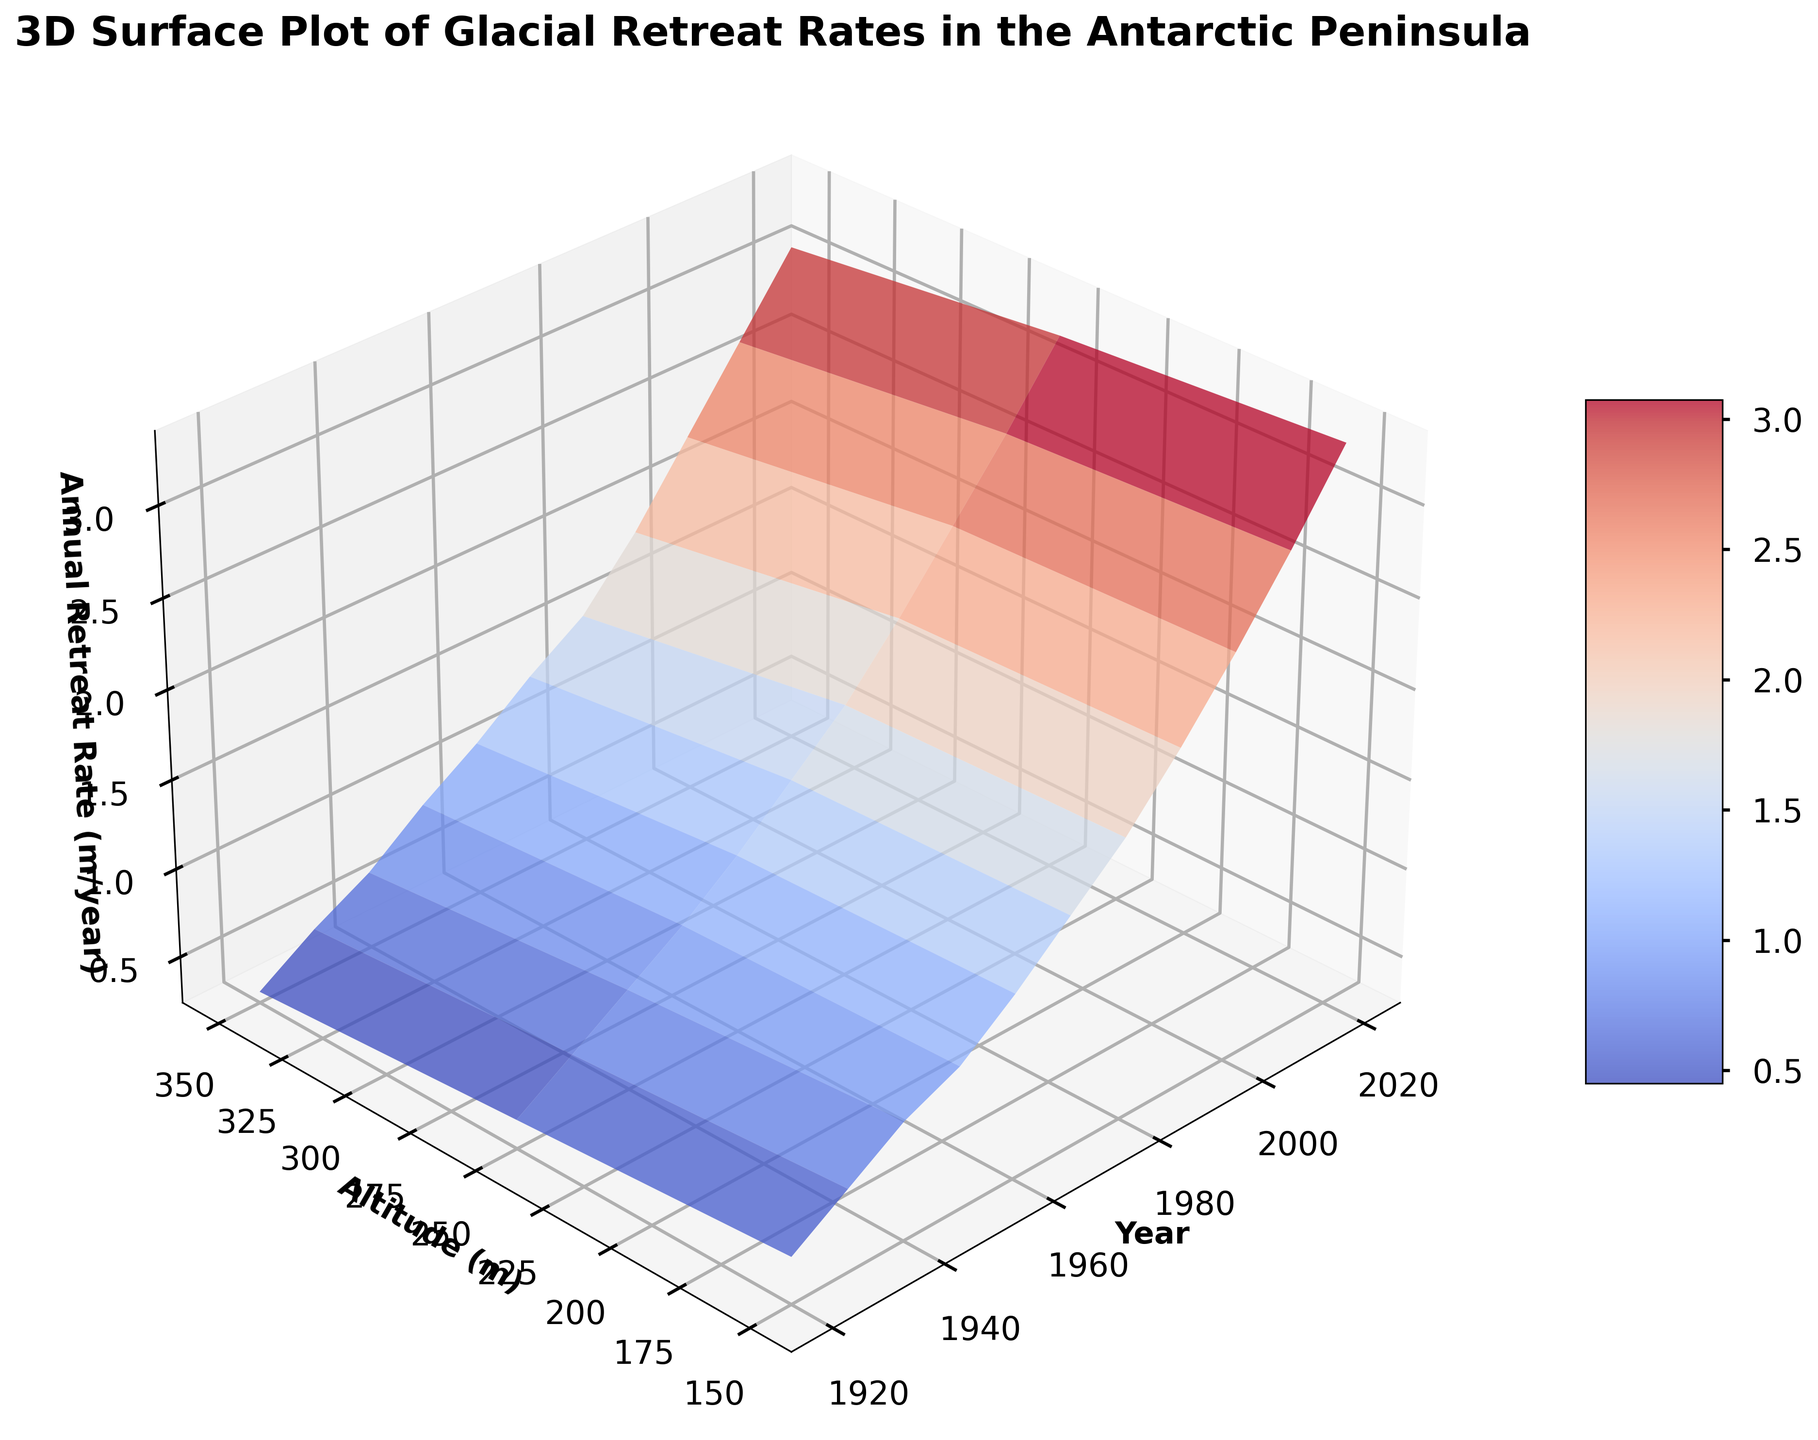What trend can you observe in the annual retreat rates over the years? To find the trend, look at how the annual retreat rates change over time. Observe the surface's color gradient and height. As the years progress from 1920 to 2020, the plot shows a general increase in the annual retreat rates, indicating an upward trend in glacial retreat rates.
Answer: Increasing trend How does the retreat rate compare between altitudes of 150 meters and 350 meters in 2020? To compare the retreat rates at 150 meters and 350 meters in 2020, look at the corresponding spots on the surface for the two altitudes in the year 2020. The altitude of 150 meters shows a higher retreat rate than the altitude of 350 meters.
Answer: Higher at 150 meters Which year shows the steepest increase in the annual retreat rate compared to the previous decade? To determine the steepest increase, observe the height difference between surfaces in consecutive decades. Between 1980 and 1990, the change in height is very steep, indicating a significant increase in the retreat rate in 1990 compared to 1980.
Answer: 1990 What is the average annual retreat rate in 2020 across all altitudes? Find the retreat rates for all altitudes in 2020 and calculate the average. The rates are approximately 3.4, 3.5, and 3.3. So, the average is (3.4 + 3.5 + 3.3) / 3 = 3.4
Answer: 3.4 Which altitude experienced the most consistent annual retreat rate increase over the past century? To determine the most consistent increase, look for the smoothest gradient and least variance in the height over years for each altitude. The 350 meters altitude appears to show a consistently increasing surface plot with a steady incline over the years.
Answer: 350 meters In which decade did the retreat rate surpass 2.0 m/year for the first time at 150 meters altitude? Look at the surface points corresponding to 150 meters altitude and identify the first year where the height crosses the 2.0 level. This happens in the 1980s.
Answer: 1980s How does the color gradient of retreat rates vary with changes in altitude? Observe the color changes along the vertical axis (altitude). As altitude increases from 150 meters to 350 meters, the colors representing retreat rates become lighter, indicating lower retreat rates at higher altitudes.
Answer: Lighter with altitude Compare the annual retreat rates in 1920 and 2020 at 150 meters altitude. What is the difference? Find the retreat rates at 150 meters altitude for the years 1920 and 2020. In 1920, it is 0.5, and in 2020, it is 3.4. The difference is 3.4 - 0.5 = 2.9.
Answer: 2.9 What is the observable difference in retreat rates between the locations at -64.290 and -64.775 latitude in the year 2000 at 250 meters altitude? Check the Z values for the given latitudes at 250 meters altitude in 2000. For both latitudes, the Z values (retreat rates) are approximately 2.6 and 2.1. The difference is 2.6 - 2.1 = 0.5.
Answer: 0.5 